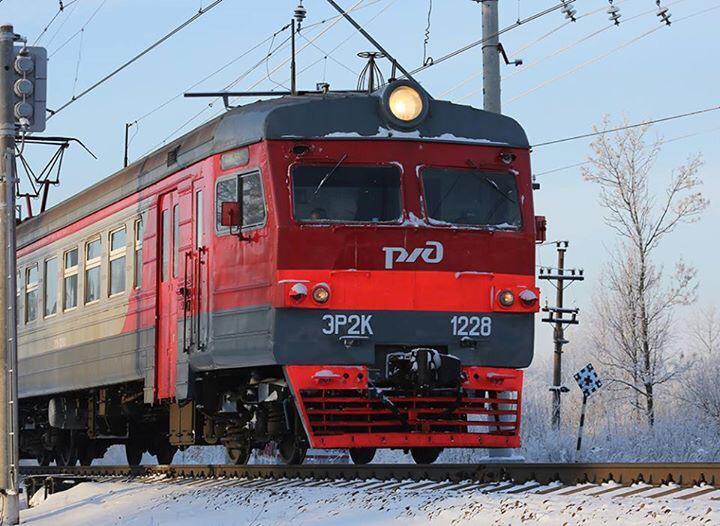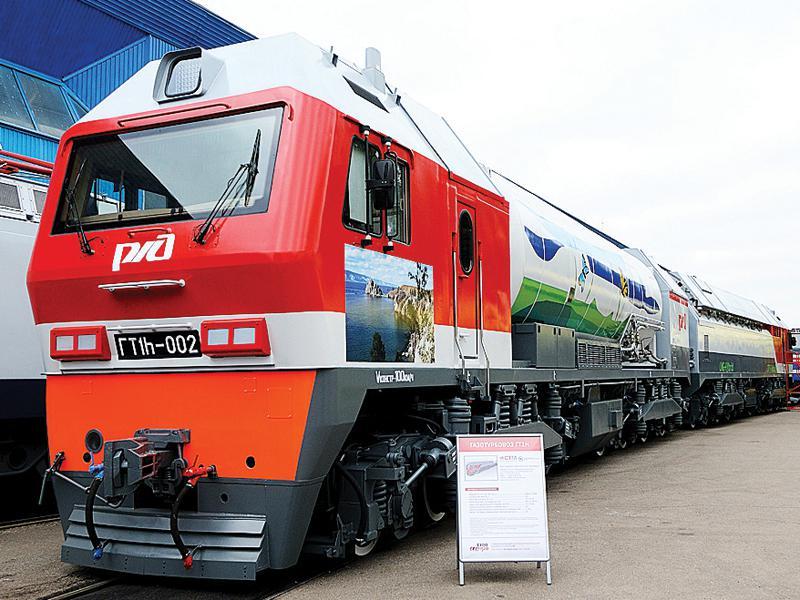The first image is the image on the left, the second image is the image on the right. Given the left and right images, does the statement "All trains are facing the same direction." hold true? Answer yes or no. No. The first image is the image on the left, the second image is the image on the right. Evaluate the accuracy of this statement regarding the images: "All trains have a reddish front, and no image shows the front of more than one train.". Is it true? Answer yes or no. Yes. 